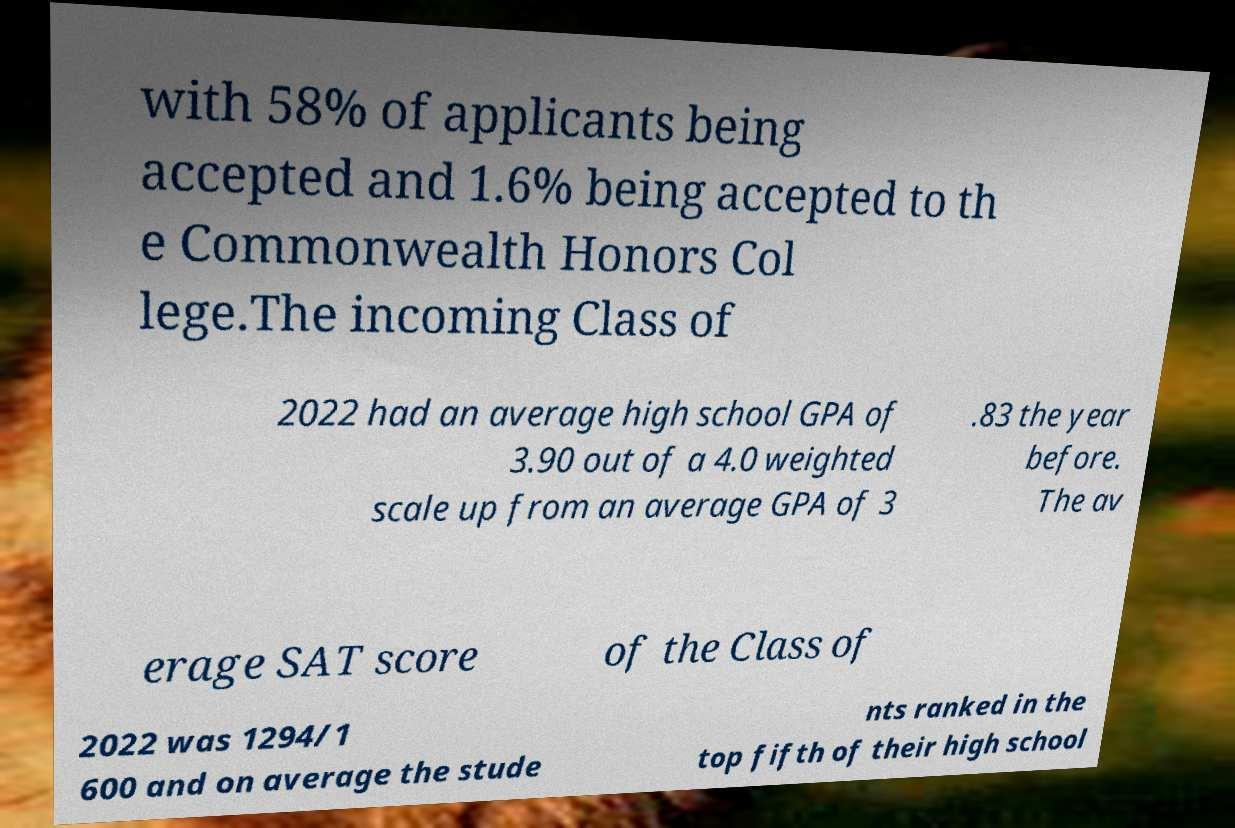Can you accurately transcribe the text from the provided image for me? with 58% of applicants being accepted and 1.6% being accepted to th e Commonwealth Honors Col lege.The incoming Class of 2022 had an average high school GPA of 3.90 out of a 4.0 weighted scale up from an average GPA of 3 .83 the year before. The av erage SAT score of the Class of 2022 was 1294/1 600 and on average the stude nts ranked in the top fifth of their high school 